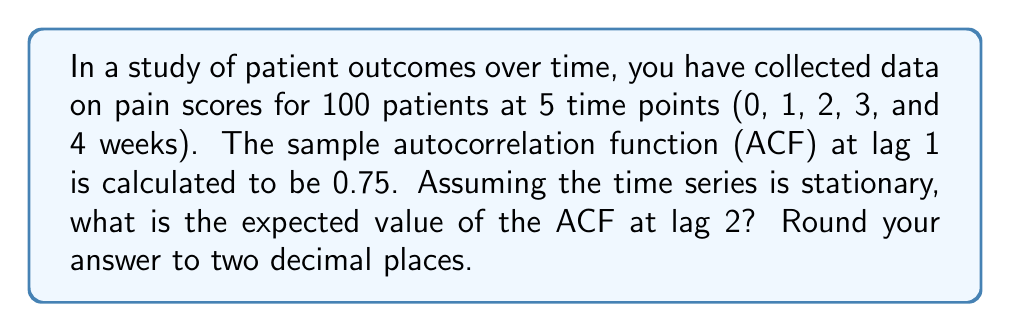Could you help me with this problem? To solve this problem, we'll follow these steps:

1) For a stationary time series, the theoretical autocorrelation function (ACF) at lag k is often modeled by an exponential decay function:

   $$\rho(k) = \rho(1)^k$$

   where $\rho(k)$ is the ACF at lag k, and $\rho(1)$ is the ACF at lag 1.

2) We are given that the sample ACF at lag 1 is 0.75. We'll use this as an estimate for $\rho(1)$:

   $$\rho(1) = 0.75$$

3) We want to find $\rho(2)$, the ACF at lag 2. Using the exponential decay model:

   $$\rho(2) = \rho(1)^2$$

4) Substituting the value we know:

   $$\rho(2) = (0.75)^2$$

5) Calculate:

   $$\rho(2) = 0.5625$$

6) Rounding to two decimal places:

   $$\rho(2) \approx 0.56$$
Answer: 0.56 